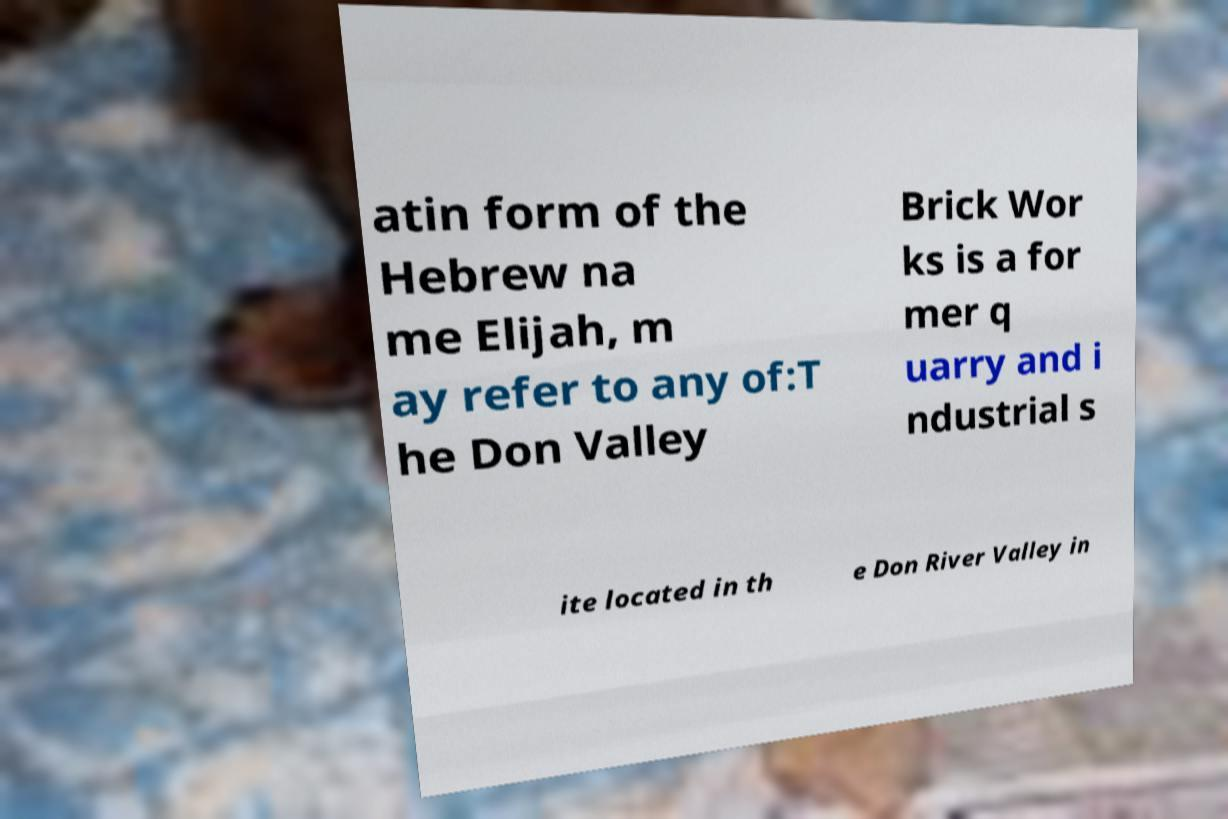Please read and relay the text visible in this image. What does it say? atin form of the Hebrew na me Elijah, m ay refer to any of:T he Don Valley Brick Wor ks is a for mer q uarry and i ndustrial s ite located in th e Don River Valley in 